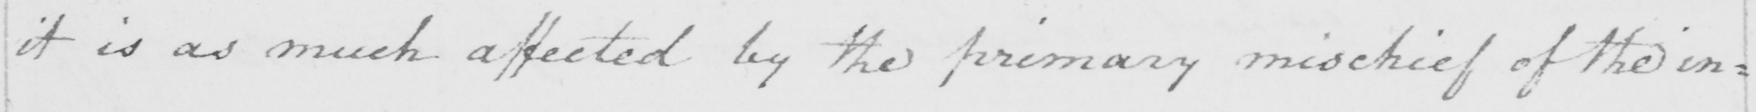Can you tell me what this handwritten text says? it is as much affected by the primary mischief of the in= 